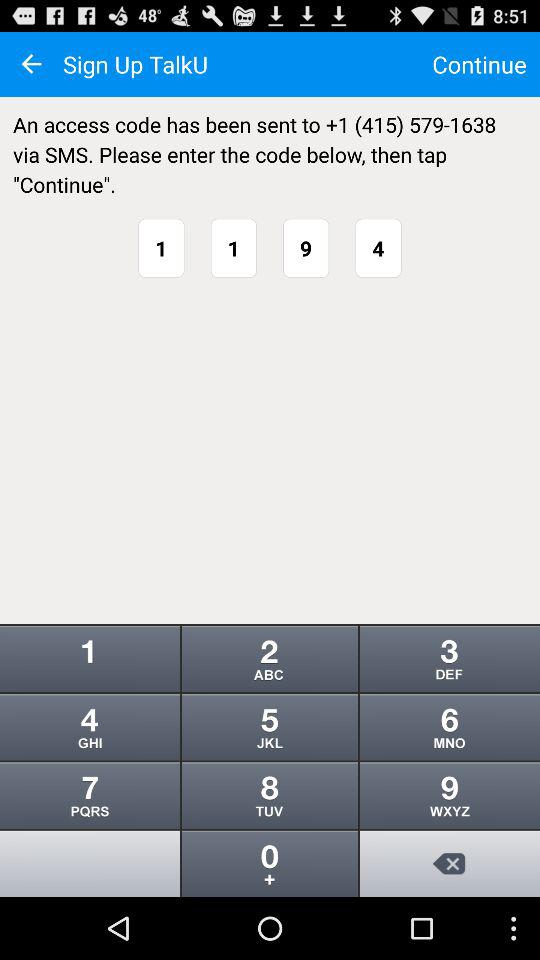How many digits are in the phone number?
Answer the question using a single word or phrase. 10 